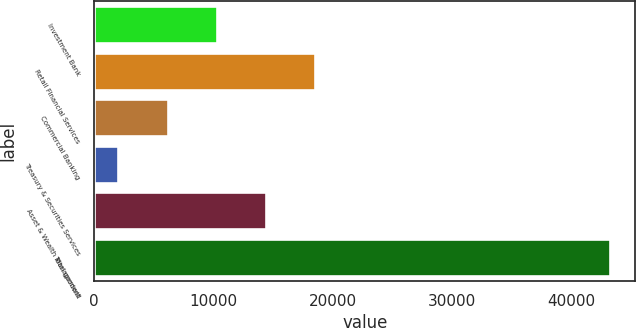<chart> <loc_0><loc_0><loc_500><loc_500><bar_chart><fcel>Investment Bank<fcel>Retail Financial Services<fcel>Commercial Banking<fcel>Treasury & Securities Services<fcel>Asset & Wealth Management<fcel>Total goodwill<nl><fcel>10275.8<fcel>18507.6<fcel>6159.9<fcel>2044<fcel>14391.7<fcel>43203<nl></chart> 